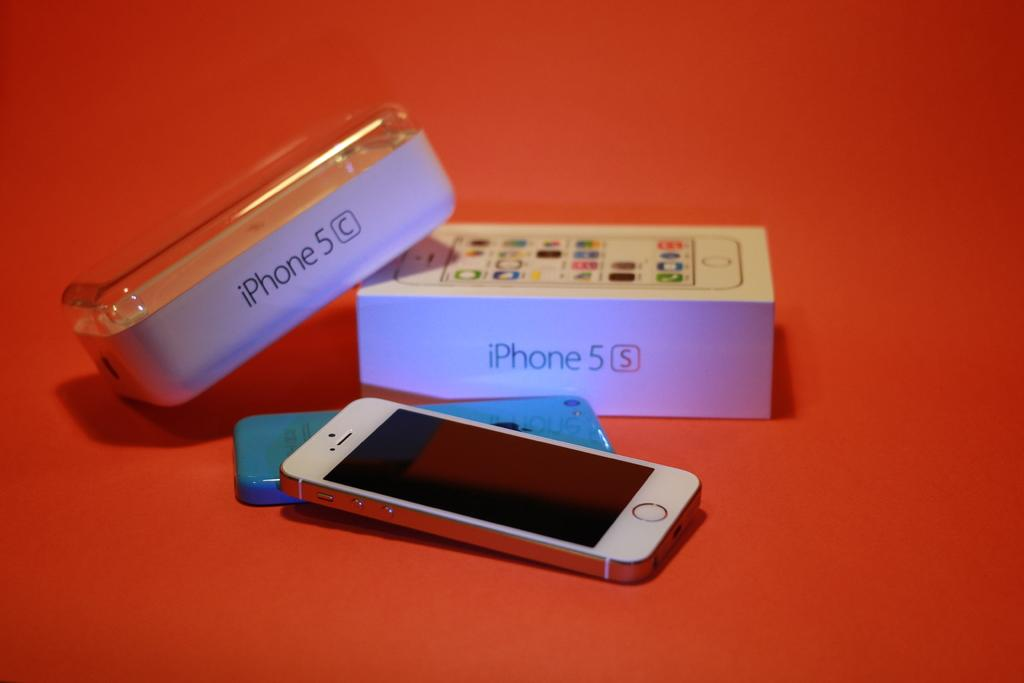<image>
Offer a succinct explanation of the picture presented. A case for an iPhone5, it is a white color 